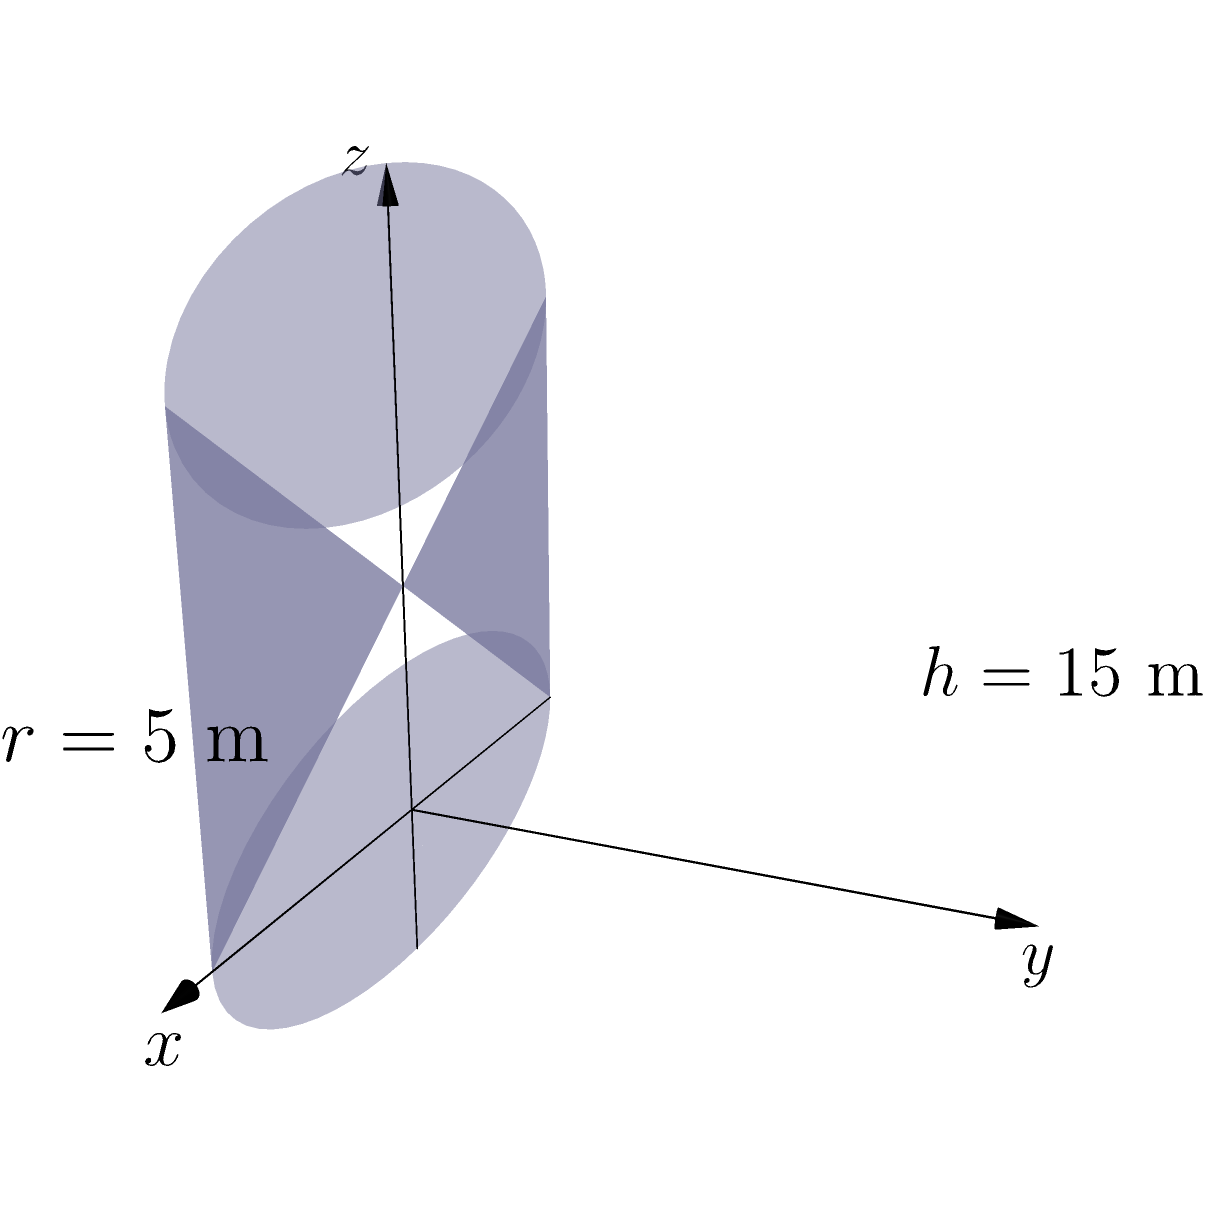The historic water tower in Sunbury can be modeled as a cylinder with radius $r=5$ meters and height $h=15$ meters. Using parametric equations, calculate the volume of the water tower. The parametric equations for a cylinder are:

$$x = r \cos(t)$$
$$y = r \sin(t)$$
$$z = u$$

Where $0 \leq t \leq 2\pi$ and $0 \leq u \leq h$. Express your answer in cubic meters. To calculate the volume of the cylindrical water tower using parametric equations, we need to set up and evaluate a double integral. Here's the step-by-step process:

1) The volume of a solid can be calculated using the formula:

   $$V = \int\int\int dV = \int\int\int |J| du dt dz$$

   Where $J$ is the Jacobian determinant.

2) For our parametric equations, we need to find the Jacobian:

   $$J = \begin{vmatrix}
   \frac{\partial x}{\partial t} & \frac{\partial x}{\partial u} \\
   \frac{\partial y}{\partial t} & \frac{\partial y}{\partial u}
   \end{vmatrix}$$

3) Calculating the partial derivatives:
   
   $$\frac{\partial x}{\partial t} = -r \sin(t)$$
   $$\frac{\partial x}{\partial u} = 0$$
   $$\frac{\partial y}{\partial t} = r \cos(t)$$
   $$\frac{\partial y}{\partial u} = 0$$

4) Substituting into the Jacobian:

   $$J = \begin{vmatrix}
   -r \sin(t) & 0 \\
   r \cos(t) & 0
   \end{vmatrix} = 0$$

5) Since the Jacobian is zero, we need to use a different approach. We can use the fact that the cross-sectional area of a cylinder is constant along its height. The area of the circular base is $\pi r^2$, and we integrate this over the height:

   $$V = \int_0^h \pi r^2 dz = \pi r^2 h$$

6) Substituting the given values:

   $$V = \pi (5\text{ m})^2 (15\text{ m}) = 375\pi \text{ m}^3$$

7) Calculating the final value:

   $$V \approx 1178.10 \text{ m}^3$$
Answer: $375\pi \text{ m}^3$ or approximately $1178.10 \text{ m}^3$ 